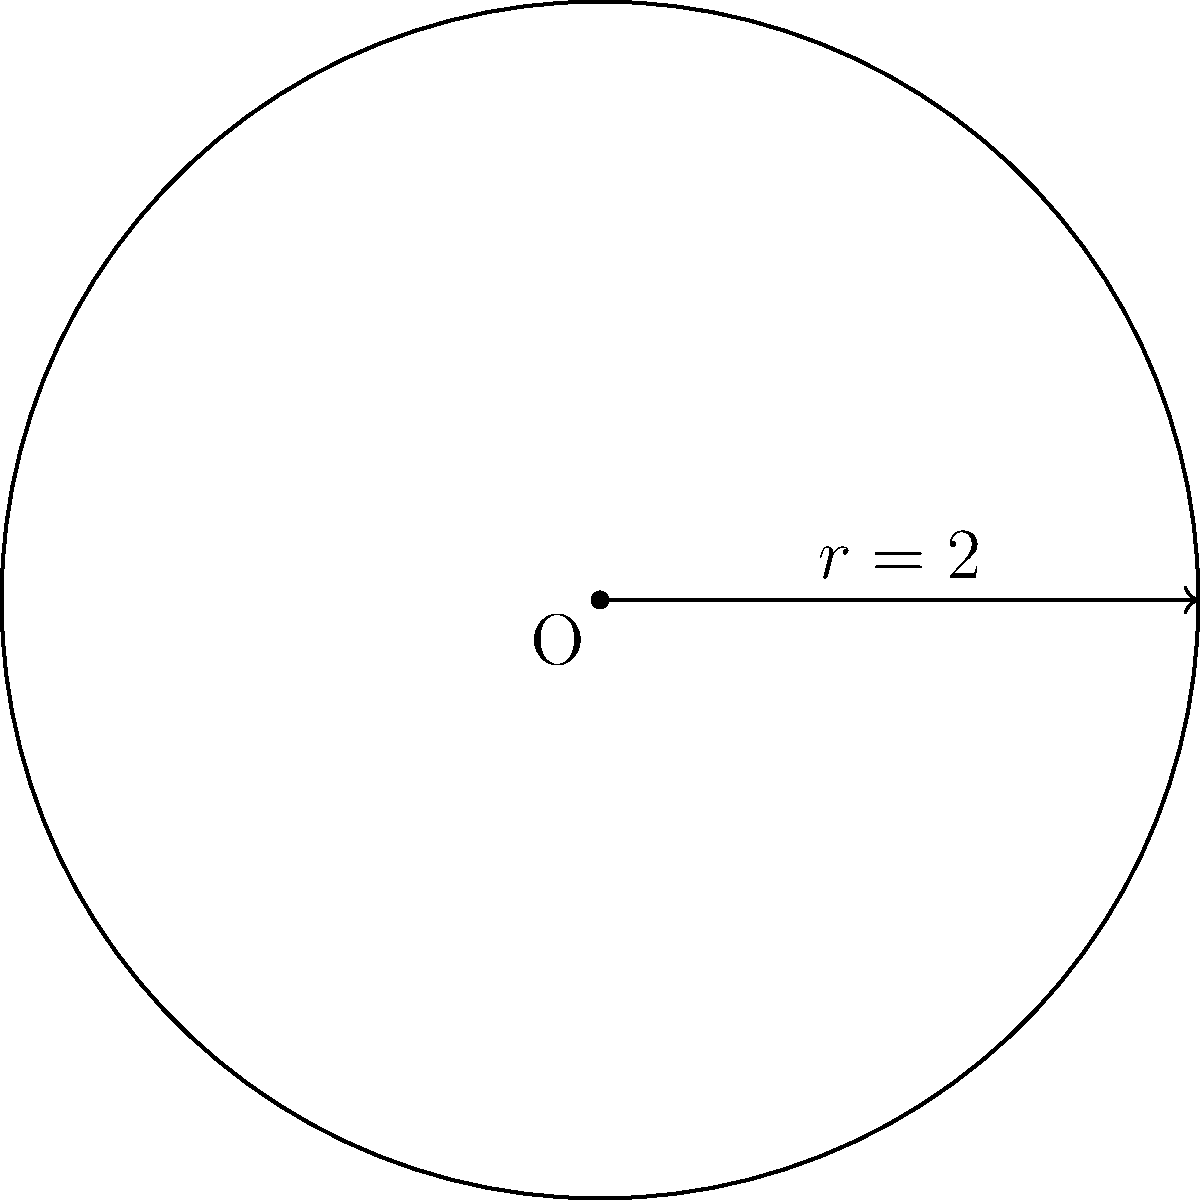You're setting up tables for a new fast-food joint. The boss wants to know the area of this circular dining table with a radius of 2 units. How would you calculate it using polar coordinates? Alright, let's break this down step-by-step:

1) In polar coordinates, the area of a region is given by the formula:

   $$A = \frac{1}{2} \int_{0}^{2\pi} r^2(\theta) d\theta$$

2) In this case, we have a circle with a constant radius of 2 units. So $r(\theta) = 2$ for all $\theta$.

3) Let's plug this into our formula:

   $$A = \frac{1}{2} \int_{0}^{2\pi} 2^2 d\theta$$

4) Simplify the inside of the integral:

   $$A = \frac{1}{2} \int_{0}^{2\pi} 4 d\theta$$

5) Now, 4 is a constant, so we can pull it out:

   $$A = \frac{1}{2} \cdot 4 \int_{0}^{2\pi} d\theta$$

6) The integral of $d\theta$ from 0 to $2\pi$ is just $2\pi$:

   $$A = \frac{1}{2} \cdot 4 \cdot 2\pi$$

7) Simplify:

   $$A = 4\pi$$

So, the area of the table is $4\pi$ square units.
Answer: $4\pi$ square units 